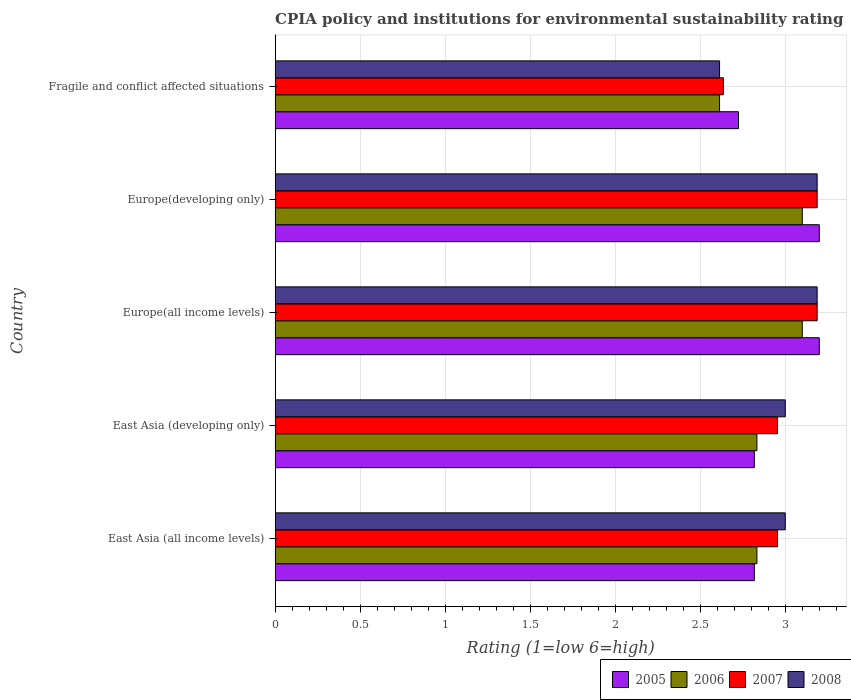How many different coloured bars are there?
Your answer should be very brief. 4. What is the label of the 3rd group of bars from the top?
Provide a short and direct response. Europe(all income levels). What is the CPIA rating in 2008 in Fragile and conflict affected situations?
Offer a terse response. 2.61. Across all countries, what is the maximum CPIA rating in 2007?
Your response must be concise. 3.19. Across all countries, what is the minimum CPIA rating in 2007?
Provide a succinct answer. 2.64. In which country was the CPIA rating in 2008 maximum?
Ensure brevity in your answer.  Europe(all income levels). In which country was the CPIA rating in 2008 minimum?
Your answer should be very brief. Fragile and conflict affected situations. What is the total CPIA rating in 2007 in the graph?
Provide a short and direct response. 14.92. What is the difference between the CPIA rating in 2006 in East Asia (developing only) and that in Europe(all income levels)?
Give a very brief answer. -0.27. What is the difference between the CPIA rating in 2006 in Europe(developing only) and the CPIA rating in 2005 in East Asia (all income levels)?
Give a very brief answer. 0.28. What is the average CPIA rating in 2005 per country?
Your answer should be compact. 2.95. What is the difference between the CPIA rating in 2008 and CPIA rating in 2006 in Europe(developing only)?
Keep it short and to the point. 0.09. What is the ratio of the CPIA rating in 2006 in Europe(all income levels) to that in Fragile and conflict affected situations?
Offer a terse response. 1.19. Is the CPIA rating in 2007 in Europe(all income levels) less than that in Fragile and conflict affected situations?
Offer a very short reply. No. Is the difference between the CPIA rating in 2008 in East Asia (developing only) and Europe(developing only) greater than the difference between the CPIA rating in 2006 in East Asia (developing only) and Europe(developing only)?
Offer a terse response. Yes. What is the difference between the highest and the second highest CPIA rating in 2007?
Make the answer very short. 0. What is the difference between the highest and the lowest CPIA rating in 2007?
Keep it short and to the point. 0.55. Is the sum of the CPIA rating in 2005 in East Asia (all income levels) and Europe(developing only) greater than the maximum CPIA rating in 2008 across all countries?
Your response must be concise. Yes. Is it the case that in every country, the sum of the CPIA rating in 2005 and CPIA rating in 2007 is greater than the sum of CPIA rating in 2008 and CPIA rating in 2006?
Make the answer very short. No. What does the 1st bar from the top in Fragile and conflict affected situations represents?
Provide a succinct answer. 2008. Is it the case that in every country, the sum of the CPIA rating in 2005 and CPIA rating in 2007 is greater than the CPIA rating in 2006?
Provide a succinct answer. Yes. How many bars are there?
Provide a succinct answer. 20. How many countries are there in the graph?
Offer a very short reply. 5. Does the graph contain any zero values?
Provide a short and direct response. No. How many legend labels are there?
Your answer should be very brief. 4. How are the legend labels stacked?
Your response must be concise. Horizontal. What is the title of the graph?
Give a very brief answer. CPIA policy and institutions for environmental sustainability rating. What is the label or title of the X-axis?
Ensure brevity in your answer.  Rating (1=low 6=high). What is the label or title of the Y-axis?
Your response must be concise. Country. What is the Rating (1=low 6=high) of 2005 in East Asia (all income levels)?
Offer a terse response. 2.82. What is the Rating (1=low 6=high) in 2006 in East Asia (all income levels)?
Provide a succinct answer. 2.83. What is the Rating (1=low 6=high) in 2007 in East Asia (all income levels)?
Your answer should be compact. 2.95. What is the Rating (1=low 6=high) in 2005 in East Asia (developing only)?
Your answer should be very brief. 2.82. What is the Rating (1=low 6=high) in 2006 in East Asia (developing only)?
Your answer should be very brief. 2.83. What is the Rating (1=low 6=high) in 2007 in East Asia (developing only)?
Keep it short and to the point. 2.95. What is the Rating (1=low 6=high) of 2008 in East Asia (developing only)?
Keep it short and to the point. 3. What is the Rating (1=low 6=high) of 2006 in Europe(all income levels)?
Make the answer very short. 3.1. What is the Rating (1=low 6=high) of 2007 in Europe(all income levels)?
Provide a short and direct response. 3.19. What is the Rating (1=low 6=high) of 2008 in Europe(all income levels)?
Offer a very short reply. 3.19. What is the Rating (1=low 6=high) in 2007 in Europe(developing only)?
Provide a short and direct response. 3.19. What is the Rating (1=low 6=high) in 2008 in Europe(developing only)?
Offer a terse response. 3.19. What is the Rating (1=low 6=high) in 2005 in Fragile and conflict affected situations?
Your answer should be compact. 2.73. What is the Rating (1=low 6=high) in 2006 in Fragile and conflict affected situations?
Provide a succinct answer. 2.61. What is the Rating (1=low 6=high) in 2007 in Fragile and conflict affected situations?
Give a very brief answer. 2.64. What is the Rating (1=low 6=high) in 2008 in Fragile and conflict affected situations?
Keep it short and to the point. 2.61. Across all countries, what is the maximum Rating (1=low 6=high) of 2005?
Offer a very short reply. 3.2. Across all countries, what is the maximum Rating (1=low 6=high) in 2007?
Offer a very short reply. 3.19. Across all countries, what is the maximum Rating (1=low 6=high) in 2008?
Keep it short and to the point. 3.19. Across all countries, what is the minimum Rating (1=low 6=high) in 2005?
Your answer should be very brief. 2.73. Across all countries, what is the minimum Rating (1=low 6=high) in 2006?
Your response must be concise. 2.61. Across all countries, what is the minimum Rating (1=low 6=high) of 2007?
Provide a succinct answer. 2.64. Across all countries, what is the minimum Rating (1=low 6=high) of 2008?
Make the answer very short. 2.61. What is the total Rating (1=low 6=high) of 2005 in the graph?
Give a very brief answer. 14.76. What is the total Rating (1=low 6=high) of 2006 in the graph?
Give a very brief answer. 14.48. What is the total Rating (1=low 6=high) in 2007 in the graph?
Your answer should be compact. 14.92. What is the total Rating (1=low 6=high) of 2008 in the graph?
Provide a short and direct response. 14.99. What is the difference between the Rating (1=low 6=high) in 2005 in East Asia (all income levels) and that in East Asia (developing only)?
Your answer should be compact. 0. What is the difference between the Rating (1=low 6=high) in 2006 in East Asia (all income levels) and that in East Asia (developing only)?
Offer a terse response. 0. What is the difference between the Rating (1=low 6=high) of 2007 in East Asia (all income levels) and that in East Asia (developing only)?
Your answer should be compact. 0. What is the difference between the Rating (1=low 6=high) of 2005 in East Asia (all income levels) and that in Europe(all income levels)?
Make the answer very short. -0.38. What is the difference between the Rating (1=low 6=high) of 2006 in East Asia (all income levels) and that in Europe(all income levels)?
Your answer should be very brief. -0.27. What is the difference between the Rating (1=low 6=high) of 2007 in East Asia (all income levels) and that in Europe(all income levels)?
Offer a very short reply. -0.23. What is the difference between the Rating (1=low 6=high) in 2008 in East Asia (all income levels) and that in Europe(all income levels)?
Your response must be concise. -0.19. What is the difference between the Rating (1=low 6=high) in 2005 in East Asia (all income levels) and that in Europe(developing only)?
Provide a succinct answer. -0.38. What is the difference between the Rating (1=low 6=high) in 2006 in East Asia (all income levels) and that in Europe(developing only)?
Ensure brevity in your answer.  -0.27. What is the difference between the Rating (1=low 6=high) of 2007 in East Asia (all income levels) and that in Europe(developing only)?
Keep it short and to the point. -0.23. What is the difference between the Rating (1=low 6=high) of 2008 in East Asia (all income levels) and that in Europe(developing only)?
Provide a succinct answer. -0.19. What is the difference between the Rating (1=low 6=high) in 2005 in East Asia (all income levels) and that in Fragile and conflict affected situations?
Ensure brevity in your answer.  0.09. What is the difference between the Rating (1=low 6=high) of 2006 in East Asia (all income levels) and that in Fragile and conflict affected situations?
Ensure brevity in your answer.  0.22. What is the difference between the Rating (1=low 6=high) of 2007 in East Asia (all income levels) and that in Fragile and conflict affected situations?
Your answer should be compact. 0.32. What is the difference between the Rating (1=low 6=high) in 2008 in East Asia (all income levels) and that in Fragile and conflict affected situations?
Your response must be concise. 0.39. What is the difference between the Rating (1=low 6=high) in 2005 in East Asia (developing only) and that in Europe(all income levels)?
Make the answer very short. -0.38. What is the difference between the Rating (1=low 6=high) of 2006 in East Asia (developing only) and that in Europe(all income levels)?
Your answer should be compact. -0.27. What is the difference between the Rating (1=low 6=high) of 2007 in East Asia (developing only) and that in Europe(all income levels)?
Offer a very short reply. -0.23. What is the difference between the Rating (1=low 6=high) in 2008 in East Asia (developing only) and that in Europe(all income levels)?
Your answer should be very brief. -0.19. What is the difference between the Rating (1=low 6=high) of 2005 in East Asia (developing only) and that in Europe(developing only)?
Keep it short and to the point. -0.38. What is the difference between the Rating (1=low 6=high) of 2006 in East Asia (developing only) and that in Europe(developing only)?
Ensure brevity in your answer.  -0.27. What is the difference between the Rating (1=low 6=high) of 2007 in East Asia (developing only) and that in Europe(developing only)?
Your response must be concise. -0.23. What is the difference between the Rating (1=low 6=high) of 2008 in East Asia (developing only) and that in Europe(developing only)?
Your answer should be very brief. -0.19. What is the difference between the Rating (1=low 6=high) of 2005 in East Asia (developing only) and that in Fragile and conflict affected situations?
Your answer should be compact. 0.09. What is the difference between the Rating (1=low 6=high) of 2006 in East Asia (developing only) and that in Fragile and conflict affected situations?
Your response must be concise. 0.22. What is the difference between the Rating (1=low 6=high) in 2007 in East Asia (developing only) and that in Fragile and conflict affected situations?
Provide a succinct answer. 0.32. What is the difference between the Rating (1=low 6=high) in 2008 in East Asia (developing only) and that in Fragile and conflict affected situations?
Ensure brevity in your answer.  0.39. What is the difference between the Rating (1=low 6=high) in 2005 in Europe(all income levels) and that in Europe(developing only)?
Ensure brevity in your answer.  0. What is the difference between the Rating (1=low 6=high) of 2005 in Europe(all income levels) and that in Fragile and conflict affected situations?
Your answer should be very brief. 0.47. What is the difference between the Rating (1=low 6=high) of 2006 in Europe(all income levels) and that in Fragile and conflict affected situations?
Give a very brief answer. 0.49. What is the difference between the Rating (1=low 6=high) in 2007 in Europe(all income levels) and that in Fragile and conflict affected situations?
Your response must be concise. 0.55. What is the difference between the Rating (1=low 6=high) in 2008 in Europe(all income levels) and that in Fragile and conflict affected situations?
Make the answer very short. 0.57. What is the difference between the Rating (1=low 6=high) of 2005 in Europe(developing only) and that in Fragile and conflict affected situations?
Offer a terse response. 0.47. What is the difference between the Rating (1=low 6=high) in 2006 in Europe(developing only) and that in Fragile and conflict affected situations?
Ensure brevity in your answer.  0.49. What is the difference between the Rating (1=low 6=high) of 2007 in Europe(developing only) and that in Fragile and conflict affected situations?
Offer a very short reply. 0.55. What is the difference between the Rating (1=low 6=high) in 2008 in Europe(developing only) and that in Fragile and conflict affected situations?
Offer a very short reply. 0.57. What is the difference between the Rating (1=low 6=high) in 2005 in East Asia (all income levels) and the Rating (1=low 6=high) in 2006 in East Asia (developing only)?
Provide a succinct answer. -0.02. What is the difference between the Rating (1=low 6=high) of 2005 in East Asia (all income levels) and the Rating (1=low 6=high) of 2007 in East Asia (developing only)?
Offer a very short reply. -0.14. What is the difference between the Rating (1=low 6=high) of 2005 in East Asia (all income levels) and the Rating (1=low 6=high) of 2008 in East Asia (developing only)?
Provide a short and direct response. -0.18. What is the difference between the Rating (1=low 6=high) of 2006 in East Asia (all income levels) and the Rating (1=low 6=high) of 2007 in East Asia (developing only)?
Your response must be concise. -0.12. What is the difference between the Rating (1=low 6=high) in 2006 in East Asia (all income levels) and the Rating (1=low 6=high) in 2008 in East Asia (developing only)?
Your answer should be compact. -0.17. What is the difference between the Rating (1=low 6=high) of 2007 in East Asia (all income levels) and the Rating (1=low 6=high) of 2008 in East Asia (developing only)?
Give a very brief answer. -0.05. What is the difference between the Rating (1=low 6=high) in 2005 in East Asia (all income levels) and the Rating (1=low 6=high) in 2006 in Europe(all income levels)?
Your answer should be compact. -0.28. What is the difference between the Rating (1=low 6=high) in 2005 in East Asia (all income levels) and the Rating (1=low 6=high) in 2007 in Europe(all income levels)?
Offer a terse response. -0.37. What is the difference between the Rating (1=low 6=high) of 2005 in East Asia (all income levels) and the Rating (1=low 6=high) of 2008 in Europe(all income levels)?
Provide a short and direct response. -0.37. What is the difference between the Rating (1=low 6=high) in 2006 in East Asia (all income levels) and the Rating (1=low 6=high) in 2007 in Europe(all income levels)?
Provide a short and direct response. -0.35. What is the difference between the Rating (1=low 6=high) of 2006 in East Asia (all income levels) and the Rating (1=low 6=high) of 2008 in Europe(all income levels)?
Make the answer very short. -0.35. What is the difference between the Rating (1=low 6=high) of 2007 in East Asia (all income levels) and the Rating (1=low 6=high) of 2008 in Europe(all income levels)?
Offer a very short reply. -0.23. What is the difference between the Rating (1=low 6=high) in 2005 in East Asia (all income levels) and the Rating (1=low 6=high) in 2006 in Europe(developing only)?
Your answer should be compact. -0.28. What is the difference between the Rating (1=low 6=high) in 2005 in East Asia (all income levels) and the Rating (1=low 6=high) in 2007 in Europe(developing only)?
Provide a succinct answer. -0.37. What is the difference between the Rating (1=low 6=high) of 2005 in East Asia (all income levels) and the Rating (1=low 6=high) of 2008 in Europe(developing only)?
Provide a succinct answer. -0.37. What is the difference between the Rating (1=low 6=high) in 2006 in East Asia (all income levels) and the Rating (1=low 6=high) in 2007 in Europe(developing only)?
Ensure brevity in your answer.  -0.35. What is the difference between the Rating (1=low 6=high) in 2006 in East Asia (all income levels) and the Rating (1=low 6=high) in 2008 in Europe(developing only)?
Offer a terse response. -0.35. What is the difference between the Rating (1=low 6=high) of 2007 in East Asia (all income levels) and the Rating (1=low 6=high) of 2008 in Europe(developing only)?
Offer a very short reply. -0.23. What is the difference between the Rating (1=low 6=high) in 2005 in East Asia (all income levels) and the Rating (1=low 6=high) in 2006 in Fragile and conflict affected situations?
Provide a succinct answer. 0.2. What is the difference between the Rating (1=low 6=high) in 2005 in East Asia (all income levels) and the Rating (1=low 6=high) in 2007 in Fragile and conflict affected situations?
Keep it short and to the point. 0.18. What is the difference between the Rating (1=low 6=high) in 2005 in East Asia (all income levels) and the Rating (1=low 6=high) in 2008 in Fragile and conflict affected situations?
Provide a succinct answer. 0.2. What is the difference between the Rating (1=low 6=high) in 2006 in East Asia (all income levels) and the Rating (1=low 6=high) in 2007 in Fragile and conflict affected situations?
Make the answer very short. 0.2. What is the difference between the Rating (1=low 6=high) of 2006 in East Asia (all income levels) and the Rating (1=low 6=high) of 2008 in Fragile and conflict affected situations?
Provide a succinct answer. 0.22. What is the difference between the Rating (1=low 6=high) of 2007 in East Asia (all income levels) and the Rating (1=low 6=high) of 2008 in Fragile and conflict affected situations?
Your response must be concise. 0.34. What is the difference between the Rating (1=low 6=high) of 2005 in East Asia (developing only) and the Rating (1=low 6=high) of 2006 in Europe(all income levels)?
Your answer should be compact. -0.28. What is the difference between the Rating (1=low 6=high) in 2005 in East Asia (developing only) and the Rating (1=low 6=high) in 2007 in Europe(all income levels)?
Provide a short and direct response. -0.37. What is the difference between the Rating (1=low 6=high) in 2005 in East Asia (developing only) and the Rating (1=low 6=high) in 2008 in Europe(all income levels)?
Your answer should be very brief. -0.37. What is the difference between the Rating (1=low 6=high) of 2006 in East Asia (developing only) and the Rating (1=low 6=high) of 2007 in Europe(all income levels)?
Keep it short and to the point. -0.35. What is the difference between the Rating (1=low 6=high) of 2006 in East Asia (developing only) and the Rating (1=low 6=high) of 2008 in Europe(all income levels)?
Offer a terse response. -0.35. What is the difference between the Rating (1=low 6=high) in 2007 in East Asia (developing only) and the Rating (1=low 6=high) in 2008 in Europe(all income levels)?
Your response must be concise. -0.23. What is the difference between the Rating (1=low 6=high) in 2005 in East Asia (developing only) and the Rating (1=low 6=high) in 2006 in Europe(developing only)?
Your answer should be compact. -0.28. What is the difference between the Rating (1=low 6=high) in 2005 in East Asia (developing only) and the Rating (1=low 6=high) in 2007 in Europe(developing only)?
Keep it short and to the point. -0.37. What is the difference between the Rating (1=low 6=high) of 2005 in East Asia (developing only) and the Rating (1=low 6=high) of 2008 in Europe(developing only)?
Your response must be concise. -0.37. What is the difference between the Rating (1=low 6=high) of 2006 in East Asia (developing only) and the Rating (1=low 6=high) of 2007 in Europe(developing only)?
Offer a very short reply. -0.35. What is the difference between the Rating (1=low 6=high) in 2006 in East Asia (developing only) and the Rating (1=low 6=high) in 2008 in Europe(developing only)?
Your response must be concise. -0.35. What is the difference between the Rating (1=low 6=high) in 2007 in East Asia (developing only) and the Rating (1=low 6=high) in 2008 in Europe(developing only)?
Give a very brief answer. -0.23. What is the difference between the Rating (1=low 6=high) in 2005 in East Asia (developing only) and the Rating (1=low 6=high) in 2006 in Fragile and conflict affected situations?
Provide a short and direct response. 0.2. What is the difference between the Rating (1=low 6=high) in 2005 in East Asia (developing only) and the Rating (1=low 6=high) in 2007 in Fragile and conflict affected situations?
Offer a very short reply. 0.18. What is the difference between the Rating (1=low 6=high) in 2005 in East Asia (developing only) and the Rating (1=low 6=high) in 2008 in Fragile and conflict affected situations?
Offer a very short reply. 0.2. What is the difference between the Rating (1=low 6=high) of 2006 in East Asia (developing only) and the Rating (1=low 6=high) of 2007 in Fragile and conflict affected situations?
Offer a terse response. 0.2. What is the difference between the Rating (1=low 6=high) of 2006 in East Asia (developing only) and the Rating (1=low 6=high) of 2008 in Fragile and conflict affected situations?
Keep it short and to the point. 0.22. What is the difference between the Rating (1=low 6=high) in 2007 in East Asia (developing only) and the Rating (1=low 6=high) in 2008 in Fragile and conflict affected situations?
Offer a very short reply. 0.34. What is the difference between the Rating (1=low 6=high) in 2005 in Europe(all income levels) and the Rating (1=low 6=high) in 2007 in Europe(developing only)?
Give a very brief answer. 0.01. What is the difference between the Rating (1=low 6=high) of 2005 in Europe(all income levels) and the Rating (1=low 6=high) of 2008 in Europe(developing only)?
Your response must be concise. 0.01. What is the difference between the Rating (1=low 6=high) of 2006 in Europe(all income levels) and the Rating (1=low 6=high) of 2007 in Europe(developing only)?
Offer a very short reply. -0.09. What is the difference between the Rating (1=low 6=high) of 2006 in Europe(all income levels) and the Rating (1=low 6=high) of 2008 in Europe(developing only)?
Your answer should be compact. -0.09. What is the difference between the Rating (1=low 6=high) of 2005 in Europe(all income levels) and the Rating (1=low 6=high) of 2006 in Fragile and conflict affected situations?
Keep it short and to the point. 0.59. What is the difference between the Rating (1=low 6=high) in 2005 in Europe(all income levels) and the Rating (1=low 6=high) in 2007 in Fragile and conflict affected situations?
Ensure brevity in your answer.  0.56. What is the difference between the Rating (1=low 6=high) of 2005 in Europe(all income levels) and the Rating (1=low 6=high) of 2008 in Fragile and conflict affected situations?
Keep it short and to the point. 0.59. What is the difference between the Rating (1=low 6=high) of 2006 in Europe(all income levels) and the Rating (1=low 6=high) of 2007 in Fragile and conflict affected situations?
Your answer should be very brief. 0.46. What is the difference between the Rating (1=low 6=high) in 2006 in Europe(all income levels) and the Rating (1=low 6=high) in 2008 in Fragile and conflict affected situations?
Make the answer very short. 0.49. What is the difference between the Rating (1=low 6=high) in 2007 in Europe(all income levels) and the Rating (1=low 6=high) in 2008 in Fragile and conflict affected situations?
Provide a succinct answer. 0.57. What is the difference between the Rating (1=low 6=high) of 2005 in Europe(developing only) and the Rating (1=low 6=high) of 2006 in Fragile and conflict affected situations?
Make the answer very short. 0.59. What is the difference between the Rating (1=low 6=high) of 2005 in Europe(developing only) and the Rating (1=low 6=high) of 2007 in Fragile and conflict affected situations?
Offer a terse response. 0.56. What is the difference between the Rating (1=low 6=high) of 2005 in Europe(developing only) and the Rating (1=low 6=high) of 2008 in Fragile and conflict affected situations?
Your answer should be very brief. 0.59. What is the difference between the Rating (1=low 6=high) of 2006 in Europe(developing only) and the Rating (1=low 6=high) of 2007 in Fragile and conflict affected situations?
Your answer should be compact. 0.46. What is the difference between the Rating (1=low 6=high) of 2006 in Europe(developing only) and the Rating (1=low 6=high) of 2008 in Fragile and conflict affected situations?
Make the answer very short. 0.49. What is the difference between the Rating (1=low 6=high) of 2007 in Europe(developing only) and the Rating (1=low 6=high) of 2008 in Fragile and conflict affected situations?
Provide a succinct answer. 0.57. What is the average Rating (1=low 6=high) of 2005 per country?
Your answer should be very brief. 2.95. What is the average Rating (1=low 6=high) in 2006 per country?
Give a very brief answer. 2.9. What is the average Rating (1=low 6=high) in 2007 per country?
Provide a short and direct response. 2.98. What is the average Rating (1=low 6=high) of 2008 per country?
Provide a succinct answer. 3. What is the difference between the Rating (1=low 6=high) of 2005 and Rating (1=low 6=high) of 2006 in East Asia (all income levels)?
Ensure brevity in your answer.  -0.02. What is the difference between the Rating (1=low 6=high) in 2005 and Rating (1=low 6=high) in 2007 in East Asia (all income levels)?
Offer a very short reply. -0.14. What is the difference between the Rating (1=low 6=high) in 2005 and Rating (1=low 6=high) in 2008 in East Asia (all income levels)?
Give a very brief answer. -0.18. What is the difference between the Rating (1=low 6=high) of 2006 and Rating (1=low 6=high) of 2007 in East Asia (all income levels)?
Your answer should be very brief. -0.12. What is the difference between the Rating (1=low 6=high) of 2006 and Rating (1=low 6=high) of 2008 in East Asia (all income levels)?
Give a very brief answer. -0.17. What is the difference between the Rating (1=low 6=high) of 2007 and Rating (1=low 6=high) of 2008 in East Asia (all income levels)?
Keep it short and to the point. -0.05. What is the difference between the Rating (1=low 6=high) of 2005 and Rating (1=low 6=high) of 2006 in East Asia (developing only)?
Make the answer very short. -0.02. What is the difference between the Rating (1=low 6=high) of 2005 and Rating (1=low 6=high) of 2007 in East Asia (developing only)?
Ensure brevity in your answer.  -0.14. What is the difference between the Rating (1=low 6=high) of 2005 and Rating (1=low 6=high) of 2008 in East Asia (developing only)?
Keep it short and to the point. -0.18. What is the difference between the Rating (1=low 6=high) in 2006 and Rating (1=low 6=high) in 2007 in East Asia (developing only)?
Ensure brevity in your answer.  -0.12. What is the difference between the Rating (1=low 6=high) of 2006 and Rating (1=low 6=high) of 2008 in East Asia (developing only)?
Keep it short and to the point. -0.17. What is the difference between the Rating (1=low 6=high) of 2007 and Rating (1=low 6=high) of 2008 in East Asia (developing only)?
Make the answer very short. -0.05. What is the difference between the Rating (1=low 6=high) of 2005 and Rating (1=low 6=high) of 2007 in Europe(all income levels)?
Keep it short and to the point. 0.01. What is the difference between the Rating (1=low 6=high) in 2005 and Rating (1=low 6=high) in 2008 in Europe(all income levels)?
Your answer should be very brief. 0.01. What is the difference between the Rating (1=low 6=high) in 2006 and Rating (1=low 6=high) in 2007 in Europe(all income levels)?
Offer a terse response. -0.09. What is the difference between the Rating (1=low 6=high) of 2006 and Rating (1=low 6=high) of 2008 in Europe(all income levels)?
Make the answer very short. -0.09. What is the difference between the Rating (1=low 6=high) in 2005 and Rating (1=low 6=high) in 2006 in Europe(developing only)?
Keep it short and to the point. 0.1. What is the difference between the Rating (1=low 6=high) in 2005 and Rating (1=low 6=high) in 2007 in Europe(developing only)?
Your answer should be compact. 0.01. What is the difference between the Rating (1=low 6=high) of 2005 and Rating (1=low 6=high) of 2008 in Europe(developing only)?
Your answer should be very brief. 0.01. What is the difference between the Rating (1=low 6=high) of 2006 and Rating (1=low 6=high) of 2007 in Europe(developing only)?
Offer a terse response. -0.09. What is the difference between the Rating (1=low 6=high) in 2006 and Rating (1=low 6=high) in 2008 in Europe(developing only)?
Make the answer very short. -0.09. What is the difference between the Rating (1=low 6=high) in 2005 and Rating (1=low 6=high) in 2006 in Fragile and conflict affected situations?
Ensure brevity in your answer.  0.11. What is the difference between the Rating (1=low 6=high) of 2005 and Rating (1=low 6=high) of 2007 in Fragile and conflict affected situations?
Provide a short and direct response. 0.09. What is the difference between the Rating (1=low 6=high) in 2005 and Rating (1=low 6=high) in 2008 in Fragile and conflict affected situations?
Offer a terse response. 0.11. What is the difference between the Rating (1=low 6=high) of 2006 and Rating (1=low 6=high) of 2007 in Fragile and conflict affected situations?
Your response must be concise. -0.02. What is the difference between the Rating (1=low 6=high) in 2007 and Rating (1=low 6=high) in 2008 in Fragile and conflict affected situations?
Offer a terse response. 0.02. What is the ratio of the Rating (1=low 6=high) of 2005 in East Asia (all income levels) to that in East Asia (developing only)?
Keep it short and to the point. 1. What is the ratio of the Rating (1=low 6=high) in 2005 in East Asia (all income levels) to that in Europe(all income levels)?
Provide a succinct answer. 0.88. What is the ratio of the Rating (1=low 6=high) in 2006 in East Asia (all income levels) to that in Europe(all income levels)?
Make the answer very short. 0.91. What is the ratio of the Rating (1=low 6=high) in 2007 in East Asia (all income levels) to that in Europe(all income levels)?
Your response must be concise. 0.93. What is the ratio of the Rating (1=low 6=high) in 2005 in East Asia (all income levels) to that in Europe(developing only)?
Provide a short and direct response. 0.88. What is the ratio of the Rating (1=low 6=high) in 2006 in East Asia (all income levels) to that in Europe(developing only)?
Provide a short and direct response. 0.91. What is the ratio of the Rating (1=low 6=high) in 2007 in East Asia (all income levels) to that in Europe(developing only)?
Your answer should be very brief. 0.93. What is the ratio of the Rating (1=low 6=high) of 2008 in East Asia (all income levels) to that in Europe(developing only)?
Your answer should be very brief. 0.94. What is the ratio of the Rating (1=low 6=high) in 2005 in East Asia (all income levels) to that in Fragile and conflict affected situations?
Your answer should be very brief. 1.03. What is the ratio of the Rating (1=low 6=high) in 2006 in East Asia (all income levels) to that in Fragile and conflict affected situations?
Your answer should be very brief. 1.08. What is the ratio of the Rating (1=low 6=high) of 2007 in East Asia (all income levels) to that in Fragile and conflict affected situations?
Your answer should be compact. 1.12. What is the ratio of the Rating (1=low 6=high) in 2008 in East Asia (all income levels) to that in Fragile and conflict affected situations?
Keep it short and to the point. 1.15. What is the ratio of the Rating (1=low 6=high) in 2005 in East Asia (developing only) to that in Europe(all income levels)?
Give a very brief answer. 0.88. What is the ratio of the Rating (1=low 6=high) in 2006 in East Asia (developing only) to that in Europe(all income levels)?
Offer a terse response. 0.91. What is the ratio of the Rating (1=low 6=high) in 2007 in East Asia (developing only) to that in Europe(all income levels)?
Give a very brief answer. 0.93. What is the ratio of the Rating (1=low 6=high) of 2005 in East Asia (developing only) to that in Europe(developing only)?
Give a very brief answer. 0.88. What is the ratio of the Rating (1=low 6=high) in 2006 in East Asia (developing only) to that in Europe(developing only)?
Provide a succinct answer. 0.91. What is the ratio of the Rating (1=low 6=high) in 2007 in East Asia (developing only) to that in Europe(developing only)?
Keep it short and to the point. 0.93. What is the ratio of the Rating (1=low 6=high) in 2005 in East Asia (developing only) to that in Fragile and conflict affected situations?
Make the answer very short. 1.03. What is the ratio of the Rating (1=low 6=high) in 2006 in East Asia (developing only) to that in Fragile and conflict affected situations?
Give a very brief answer. 1.08. What is the ratio of the Rating (1=low 6=high) of 2007 in East Asia (developing only) to that in Fragile and conflict affected situations?
Give a very brief answer. 1.12. What is the ratio of the Rating (1=low 6=high) of 2008 in East Asia (developing only) to that in Fragile and conflict affected situations?
Ensure brevity in your answer.  1.15. What is the ratio of the Rating (1=low 6=high) of 2005 in Europe(all income levels) to that in Europe(developing only)?
Provide a short and direct response. 1. What is the ratio of the Rating (1=low 6=high) in 2007 in Europe(all income levels) to that in Europe(developing only)?
Offer a very short reply. 1. What is the ratio of the Rating (1=low 6=high) in 2008 in Europe(all income levels) to that in Europe(developing only)?
Offer a terse response. 1. What is the ratio of the Rating (1=low 6=high) of 2005 in Europe(all income levels) to that in Fragile and conflict affected situations?
Provide a succinct answer. 1.17. What is the ratio of the Rating (1=low 6=high) in 2006 in Europe(all income levels) to that in Fragile and conflict affected situations?
Offer a terse response. 1.19. What is the ratio of the Rating (1=low 6=high) in 2007 in Europe(all income levels) to that in Fragile and conflict affected situations?
Offer a very short reply. 1.21. What is the ratio of the Rating (1=low 6=high) of 2008 in Europe(all income levels) to that in Fragile and conflict affected situations?
Your response must be concise. 1.22. What is the ratio of the Rating (1=low 6=high) of 2005 in Europe(developing only) to that in Fragile and conflict affected situations?
Keep it short and to the point. 1.17. What is the ratio of the Rating (1=low 6=high) of 2006 in Europe(developing only) to that in Fragile and conflict affected situations?
Provide a succinct answer. 1.19. What is the ratio of the Rating (1=low 6=high) in 2007 in Europe(developing only) to that in Fragile and conflict affected situations?
Your answer should be compact. 1.21. What is the ratio of the Rating (1=low 6=high) of 2008 in Europe(developing only) to that in Fragile and conflict affected situations?
Provide a short and direct response. 1.22. What is the difference between the highest and the second highest Rating (1=low 6=high) in 2005?
Your answer should be compact. 0. What is the difference between the highest and the second highest Rating (1=low 6=high) in 2006?
Keep it short and to the point. 0. What is the difference between the highest and the second highest Rating (1=low 6=high) in 2008?
Provide a short and direct response. 0. What is the difference between the highest and the lowest Rating (1=low 6=high) of 2005?
Provide a succinct answer. 0.47. What is the difference between the highest and the lowest Rating (1=low 6=high) in 2006?
Your answer should be very brief. 0.49. What is the difference between the highest and the lowest Rating (1=low 6=high) of 2007?
Offer a terse response. 0.55. What is the difference between the highest and the lowest Rating (1=low 6=high) of 2008?
Provide a succinct answer. 0.57. 